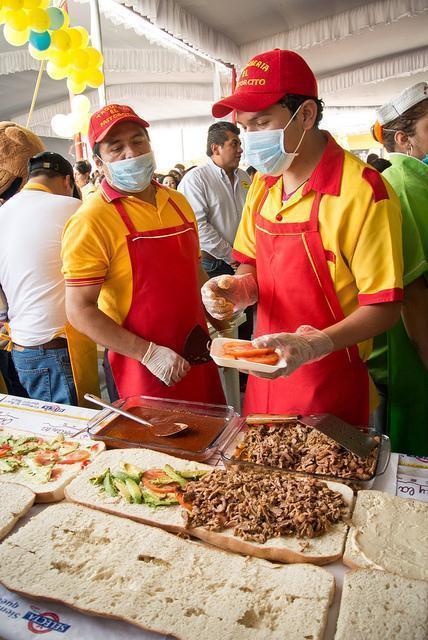These people are making what kind of food?
Make your selection and explain in format: 'Answer: answer
Rationale: rationale.'
Options: Mexican, halal, kosher, chinese. Answer: mexican.
Rationale: They are spreading shredded meat and topping with a mole sauce. 